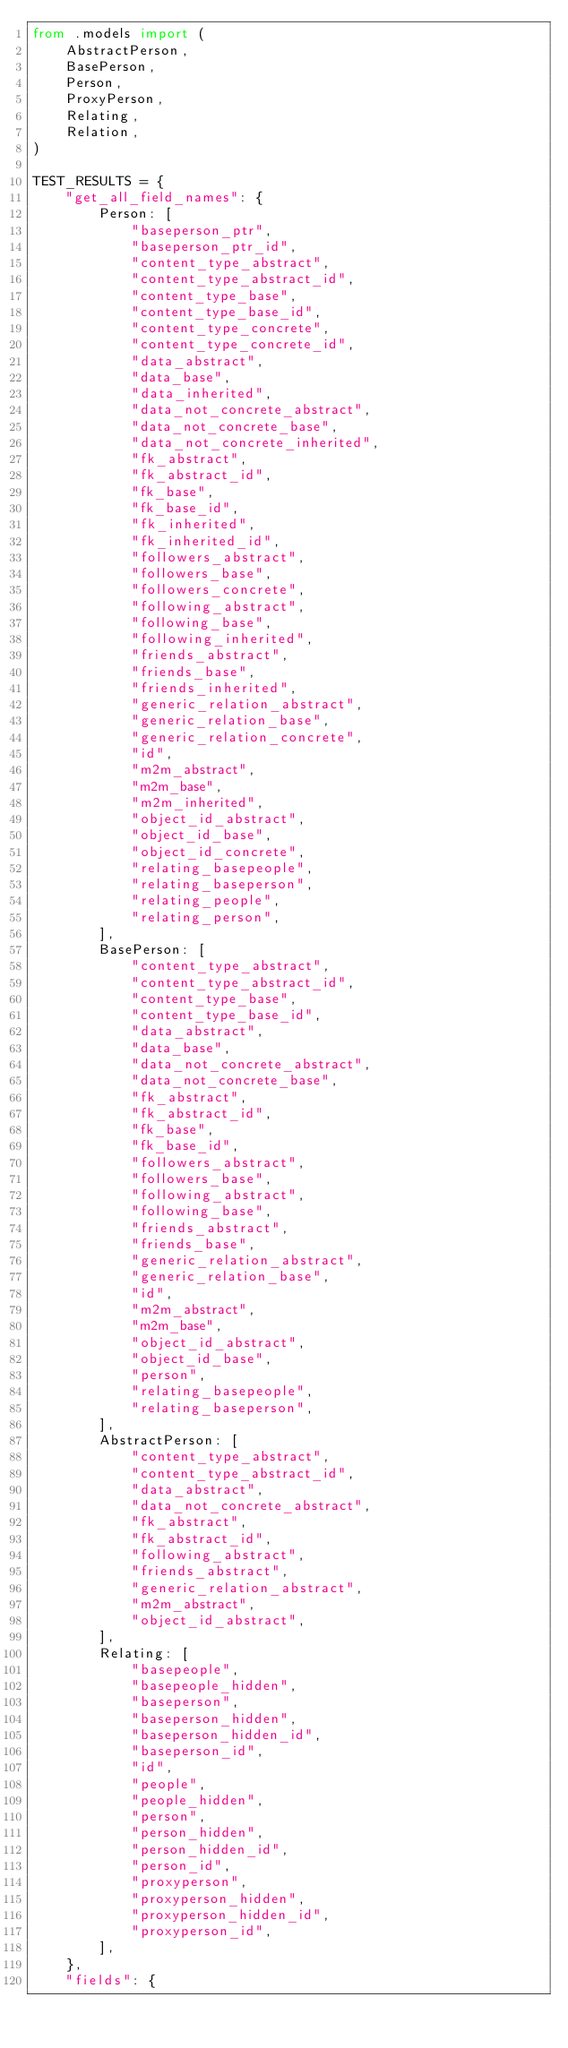Convert code to text. <code><loc_0><loc_0><loc_500><loc_500><_Python_>from .models import (
    AbstractPerson,
    BasePerson,
    Person,
    ProxyPerson,
    Relating,
    Relation,
)

TEST_RESULTS = {
    "get_all_field_names": {
        Person: [
            "baseperson_ptr",
            "baseperson_ptr_id",
            "content_type_abstract",
            "content_type_abstract_id",
            "content_type_base",
            "content_type_base_id",
            "content_type_concrete",
            "content_type_concrete_id",
            "data_abstract",
            "data_base",
            "data_inherited",
            "data_not_concrete_abstract",
            "data_not_concrete_base",
            "data_not_concrete_inherited",
            "fk_abstract",
            "fk_abstract_id",
            "fk_base",
            "fk_base_id",
            "fk_inherited",
            "fk_inherited_id",
            "followers_abstract",
            "followers_base",
            "followers_concrete",
            "following_abstract",
            "following_base",
            "following_inherited",
            "friends_abstract",
            "friends_base",
            "friends_inherited",
            "generic_relation_abstract",
            "generic_relation_base",
            "generic_relation_concrete",
            "id",
            "m2m_abstract",
            "m2m_base",
            "m2m_inherited",
            "object_id_abstract",
            "object_id_base",
            "object_id_concrete",
            "relating_basepeople",
            "relating_baseperson",
            "relating_people",
            "relating_person",
        ],
        BasePerson: [
            "content_type_abstract",
            "content_type_abstract_id",
            "content_type_base",
            "content_type_base_id",
            "data_abstract",
            "data_base",
            "data_not_concrete_abstract",
            "data_not_concrete_base",
            "fk_abstract",
            "fk_abstract_id",
            "fk_base",
            "fk_base_id",
            "followers_abstract",
            "followers_base",
            "following_abstract",
            "following_base",
            "friends_abstract",
            "friends_base",
            "generic_relation_abstract",
            "generic_relation_base",
            "id",
            "m2m_abstract",
            "m2m_base",
            "object_id_abstract",
            "object_id_base",
            "person",
            "relating_basepeople",
            "relating_baseperson",
        ],
        AbstractPerson: [
            "content_type_abstract",
            "content_type_abstract_id",
            "data_abstract",
            "data_not_concrete_abstract",
            "fk_abstract",
            "fk_abstract_id",
            "following_abstract",
            "friends_abstract",
            "generic_relation_abstract",
            "m2m_abstract",
            "object_id_abstract",
        ],
        Relating: [
            "basepeople",
            "basepeople_hidden",
            "baseperson",
            "baseperson_hidden",
            "baseperson_hidden_id",
            "baseperson_id",
            "id",
            "people",
            "people_hidden",
            "person",
            "person_hidden",
            "person_hidden_id",
            "person_id",
            "proxyperson",
            "proxyperson_hidden",
            "proxyperson_hidden_id",
            "proxyperson_id",
        ],
    },
    "fields": {</code> 